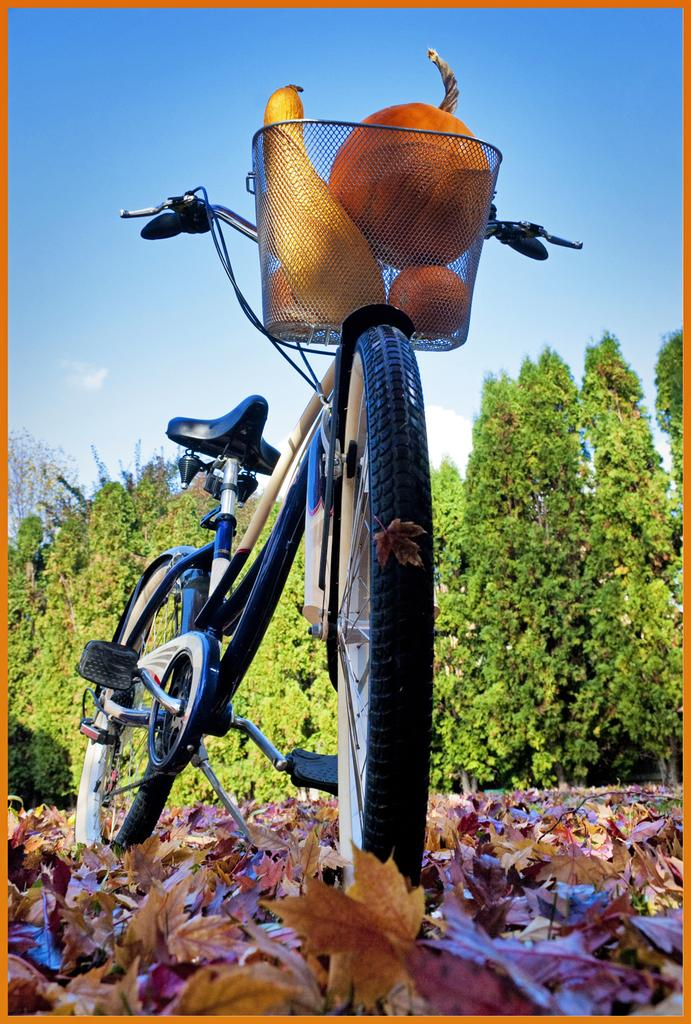Where was the image taken? The image was clicked outside. What is the main subject in the middle of the image? There is a bicycle in the middle of the image. What is placed in the bicycle's basket? There are fruits in the bicycle's basket. What type of vegetation can be seen in the image? There are trees in the image. What is visible at the top of the image? The sky is visible at the top of the image. Who is the owner of the fowl in the image? There is no fowl present in the image. How many bikes are visible in the image? There is only one bicycle visible in the image. 